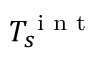<formula> <loc_0><loc_0><loc_500><loc_500>T _ { s } ^ { i n t }</formula> 